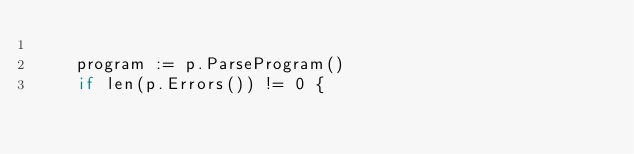<code> <loc_0><loc_0><loc_500><loc_500><_Go_>
		program := p.ParseProgram()
		if len(p.Errors()) != 0 {</code> 